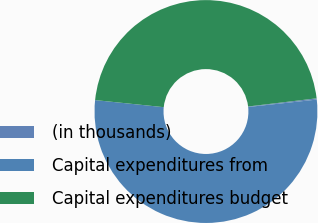Convert chart to OTSL. <chart><loc_0><loc_0><loc_500><loc_500><pie_chart><fcel>(in thousands)<fcel>Capital expenditures from<fcel>Capital expenditures budget<nl><fcel>0.18%<fcel>53.35%<fcel>46.47%<nl></chart> 